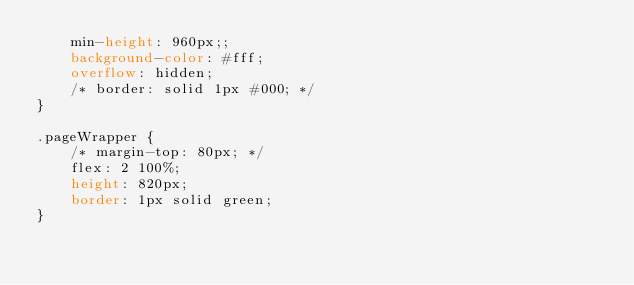<code> <loc_0><loc_0><loc_500><loc_500><_CSS_>    min-height: 960px;;
    background-color: #fff;
    overflow: hidden;
    /* border: solid 1px #000; */
}

.pageWrapper {
    /* margin-top: 80px; */
    flex: 2 100%;
    height: 820px;
    border: 1px solid green;
}

</code> 